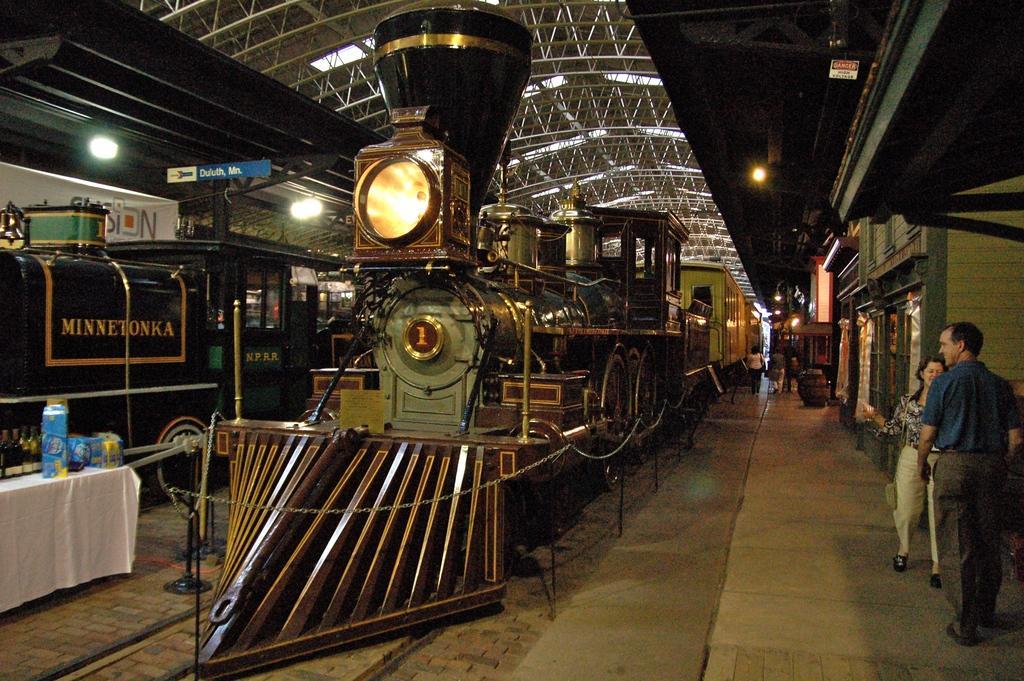Describe this image in one or two sentences. This is the picture of a place where we have a train to which there is a light and around there are some other things, people and some lights to the roof. 